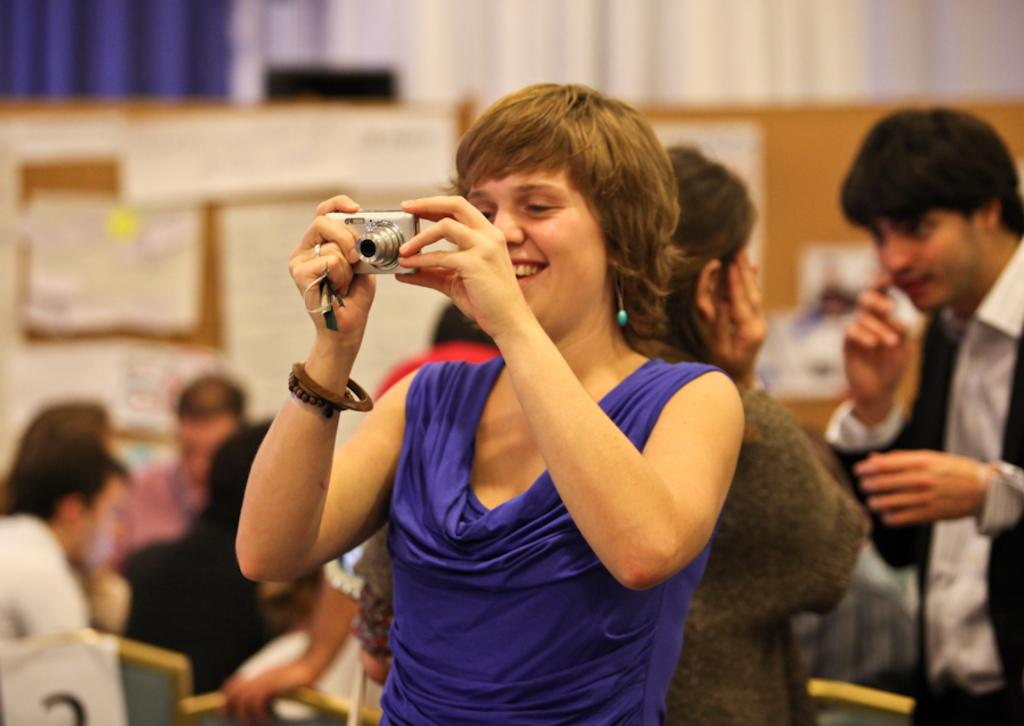Who is the main subject in the image? There is a woman in the image. What is the woman doing in the image? The woman is smiling and holding a camera. Can you describe the people in the background of the image? There are people standing and seated on chairs in the background of the image. What type of bait is the woman using to catch fish in the image? There is no bait or fishing activity present in the image; the woman is holding a camera. What kind of box is visible in the image? There is no box present in the image. 